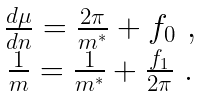<formula> <loc_0><loc_0><loc_500><loc_500>\begin{array} { c c } \frac { d \mu } { d n } = \frac { 2 \pi } { m ^ { * } } + f _ { 0 } \ , \\ \frac { 1 } { m } = \frac { 1 } { m ^ { * } } + \frac { f _ { 1 } } { 2 \pi } \ . \end{array}</formula> 